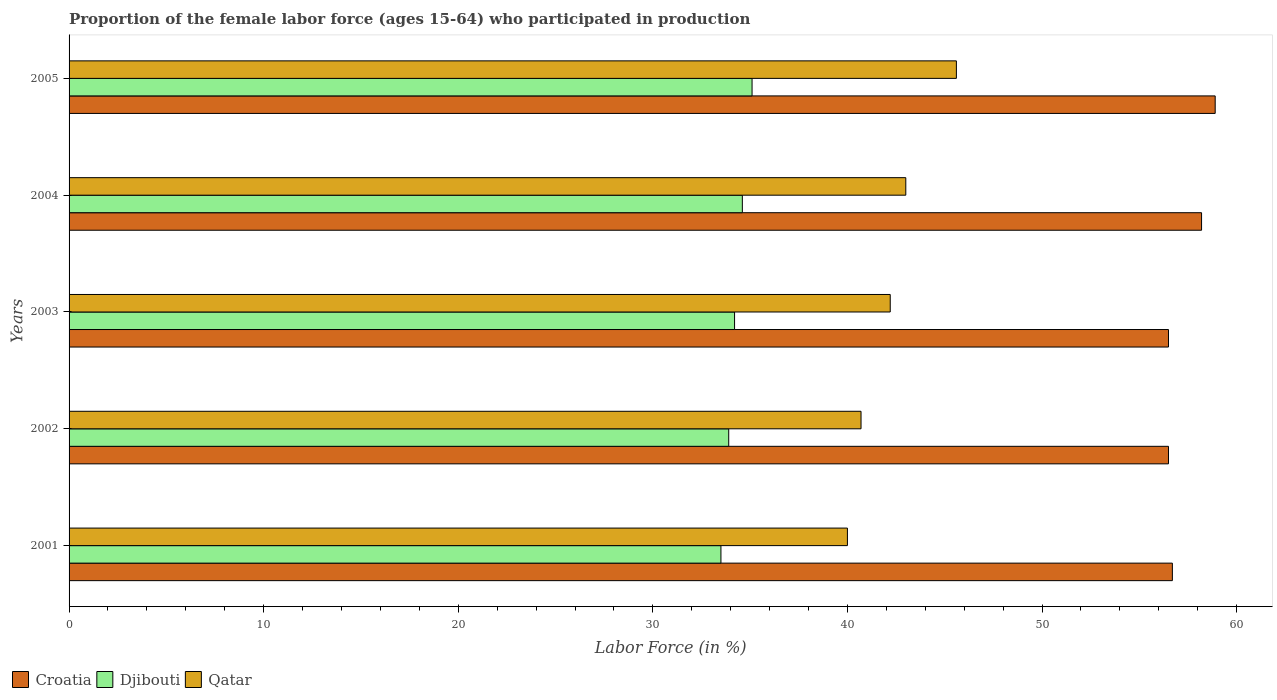How many groups of bars are there?
Offer a very short reply. 5. How many bars are there on the 5th tick from the bottom?
Make the answer very short. 3. What is the proportion of the female labor force who participated in production in Croatia in 2005?
Your answer should be very brief. 58.9. Across all years, what is the maximum proportion of the female labor force who participated in production in Djibouti?
Offer a very short reply. 35.1. Across all years, what is the minimum proportion of the female labor force who participated in production in Qatar?
Give a very brief answer. 40. In which year was the proportion of the female labor force who participated in production in Djibouti minimum?
Provide a short and direct response. 2001. What is the total proportion of the female labor force who participated in production in Djibouti in the graph?
Provide a succinct answer. 171.3. What is the difference between the proportion of the female labor force who participated in production in Qatar in 2002 and that in 2004?
Make the answer very short. -2.3. What is the difference between the proportion of the female labor force who participated in production in Djibouti in 2004 and the proportion of the female labor force who participated in production in Croatia in 2001?
Provide a short and direct response. -22.1. What is the average proportion of the female labor force who participated in production in Qatar per year?
Your response must be concise. 42.3. In the year 2002, what is the difference between the proportion of the female labor force who participated in production in Qatar and proportion of the female labor force who participated in production in Croatia?
Offer a very short reply. -15.8. What is the ratio of the proportion of the female labor force who participated in production in Croatia in 2003 to that in 2004?
Your answer should be compact. 0.97. Is the difference between the proportion of the female labor force who participated in production in Qatar in 2002 and 2005 greater than the difference between the proportion of the female labor force who participated in production in Croatia in 2002 and 2005?
Make the answer very short. No. What is the difference between the highest and the second highest proportion of the female labor force who participated in production in Djibouti?
Offer a terse response. 0.5. What is the difference between the highest and the lowest proportion of the female labor force who participated in production in Djibouti?
Your answer should be compact. 1.6. In how many years, is the proportion of the female labor force who participated in production in Qatar greater than the average proportion of the female labor force who participated in production in Qatar taken over all years?
Make the answer very short. 2. What does the 1st bar from the top in 2003 represents?
Ensure brevity in your answer.  Qatar. What does the 1st bar from the bottom in 2004 represents?
Ensure brevity in your answer.  Croatia. Is it the case that in every year, the sum of the proportion of the female labor force who participated in production in Djibouti and proportion of the female labor force who participated in production in Croatia is greater than the proportion of the female labor force who participated in production in Qatar?
Offer a very short reply. Yes. Are all the bars in the graph horizontal?
Keep it short and to the point. Yes. Does the graph contain grids?
Offer a terse response. No. Where does the legend appear in the graph?
Keep it short and to the point. Bottom left. How many legend labels are there?
Your answer should be very brief. 3. What is the title of the graph?
Ensure brevity in your answer.  Proportion of the female labor force (ages 15-64) who participated in production. Does "Swaziland" appear as one of the legend labels in the graph?
Your answer should be compact. No. What is the Labor Force (in %) in Croatia in 2001?
Offer a terse response. 56.7. What is the Labor Force (in %) in Djibouti in 2001?
Keep it short and to the point. 33.5. What is the Labor Force (in %) in Qatar in 2001?
Your answer should be compact. 40. What is the Labor Force (in %) in Croatia in 2002?
Offer a very short reply. 56.5. What is the Labor Force (in %) in Djibouti in 2002?
Offer a terse response. 33.9. What is the Labor Force (in %) in Qatar in 2002?
Keep it short and to the point. 40.7. What is the Labor Force (in %) of Croatia in 2003?
Your answer should be compact. 56.5. What is the Labor Force (in %) in Djibouti in 2003?
Offer a terse response. 34.2. What is the Labor Force (in %) of Qatar in 2003?
Make the answer very short. 42.2. What is the Labor Force (in %) in Croatia in 2004?
Your response must be concise. 58.2. What is the Labor Force (in %) of Djibouti in 2004?
Keep it short and to the point. 34.6. What is the Labor Force (in %) of Croatia in 2005?
Your response must be concise. 58.9. What is the Labor Force (in %) in Djibouti in 2005?
Your response must be concise. 35.1. What is the Labor Force (in %) of Qatar in 2005?
Give a very brief answer. 45.6. Across all years, what is the maximum Labor Force (in %) of Croatia?
Ensure brevity in your answer.  58.9. Across all years, what is the maximum Labor Force (in %) in Djibouti?
Offer a terse response. 35.1. Across all years, what is the maximum Labor Force (in %) of Qatar?
Your response must be concise. 45.6. Across all years, what is the minimum Labor Force (in %) in Croatia?
Give a very brief answer. 56.5. Across all years, what is the minimum Labor Force (in %) in Djibouti?
Ensure brevity in your answer.  33.5. What is the total Labor Force (in %) of Croatia in the graph?
Provide a succinct answer. 286.8. What is the total Labor Force (in %) in Djibouti in the graph?
Keep it short and to the point. 171.3. What is the total Labor Force (in %) of Qatar in the graph?
Offer a very short reply. 211.5. What is the difference between the Labor Force (in %) in Djibouti in 2001 and that in 2003?
Offer a terse response. -0.7. What is the difference between the Labor Force (in %) in Qatar in 2001 and that in 2003?
Ensure brevity in your answer.  -2.2. What is the difference between the Labor Force (in %) of Croatia in 2001 and that in 2005?
Your answer should be very brief. -2.2. What is the difference between the Labor Force (in %) of Qatar in 2001 and that in 2005?
Your answer should be compact. -5.6. What is the difference between the Labor Force (in %) in Croatia in 2002 and that in 2003?
Your answer should be compact. 0. What is the difference between the Labor Force (in %) of Djibouti in 2002 and that in 2003?
Provide a short and direct response. -0.3. What is the difference between the Labor Force (in %) in Qatar in 2002 and that in 2003?
Give a very brief answer. -1.5. What is the difference between the Labor Force (in %) in Qatar in 2002 and that in 2004?
Provide a succinct answer. -2.3. What is the difference between the Labor Force (in %) in Croatia in 2003 and that in 2005?
Provide a short and direct response. -2.4. What is the difference between the Labor Force (in %) of Qatar in 2003 and that in 2005?
Ensure brevity in your answer.  -3.4. What is the difference between the Labor Force (in %) in Croatia in 2004 and that in 2005?
Offer a terse response. -0.7. What is the difference between the Labor Force (in %) in Croatia in 2001 and the Labor Force (in %) in Djibouti in 2002?
Keep it short and to the point. 22.8. What is the difference between the Labor Force (in %) of Croatia in 2001 and the Labor Force (in %) of Qatar in 2002?
Your answer should be very brief. 16. What is the difference between the Labor Force (in %) in Djibouti in 2001 and the Labor Force (in %) in Qatar in 2002?
Keep it short and to the point. -7.2. What is the difference between the Labor Force (in %) in Djibouti in 2001 and the Labor Force (in %) in Qatar in 2003?
Keep it short and to the point. -8.7. What is the difference between the Labor Force (in %) in Croatia in 2001 and the Labor Force (in %) in Djibouti in 2004?
Provide a short and direct response. 22.1. What is the difference between the Labor Force (in %) of Croatia in 2001 and the Labor Force (in %) of Qatar in 2004?
Ensure brevity in your answer.  13.7. What is the difference between the Labor Force (in %) in Djibouti in 2001 and the Labor Force (in %) in Qatar in 2004?
Your answer should be very brief. -9.5. What is the difference between the Labor Force (in %) in Croatia in 2001 and the Labor Force (in %) in Djibouti in 2005?
Offer a very short reply. 21.6. What is the difference between the Labor Force (in %) in Croatia in 2001 and the Labor Force (in %) in Qatar in 2005?
Ensure brevity in your answer.  11.1. What is the difference between the Labor Force (in %) in Djibouti in 2001 and the Labor Force (in %) in Qatar in 2005?
Your response must be concise. -12.1. What is the difference between the Labor Force (in %) of Croatia in 2002 and the Labor Force (in %) of Djibouti in 2003?
Provide a succinct answer. 22.3. What is the difference between the Labor Force (in %) in Croatia in 2002 and the Labor Force (in %) in Qatar in 2003?
Offer a very short reply. 14.3. What is the difference between the Labor Force (in %) of Croatia in 2002 and the Labor Force (in %) of Djibouti in 2004?
Provide a succinct answer. 21.9. What is the difference between the Labor Force (in %) of Croatia in 2002 and the Labor Force (in %) of Qatar in 2004?
Provide a short and direct response. 13.5. What is the difference between the Labor Force (in %) in Croatia in 2002 and the Labor Force (in %) in Djibouti in 2005?
Provide a short and direct response. 21.4. What is the difference between the Labor Force (in %) of Croatia in 2003 and the Labor Force (in %) of Djibouti in 2004?
Provide a short and direct response. 21.9. What is the difference between the Labor Force (in %) of Croatia in 2003 and the Labor Force (in %) of Qatar in 2004?
Offer a very short reply. 13.5. What is the difference between the Labor Force (in %) of Djibouti in 2003 and the Labor Force (in %) of Qatar in 2004?
Provide a succinct answer. -8.8. What is the difference between the Labor Force (in %) in Croatia in 2003 and the Labor Force (in %) in Djibouti in 2005?
Offer a terse response. 21.4. What is the difference between the Labor Force (in %) in Croatia in 2004 and the Labor Force (in %) in Djibouti in 2005?
Give a very brief answer. 23.1. What is the difference between the Labor Force (in %) in Croatia in 2004 and the Labor Force (in %) in Qatar in 2005?
Give a very brief answer. 12.6. What is the difference between the Labor Force (in %) in Djibouti in 2004 and the Labor Force (in %) in Qatar in 2005?
Your response must be concise. -11. What is the average Labor Force (in %) of Croatia per year?
Offer a very short reply. 57.36. What is the average Labor Force (in %) of Djibouti per year?
Your answer should be very brief. 34.26. What is the average Labor Force (in %) of Qatar per year?
Ensure brevity in your answer.  42.3. In the year 2001, what is the difference between the Labor Force (in %) of Croatia and Labor Force (in %) of Djibouti?
Offer a very short reply. 23.2. In the year 2002, what is the difference between the Labor Force (in %) of Croatia and Labor Force (in %) of Djibouti?
Offer a terse response. 22.6. In the year 2003, what is the difference between the Labor Force (in %) in Croatia and Labor Force (in %) in Djibouti?
Offer a terse response. 22.3. In the year 2003, what is the difference between the Labor Force (in %) of Croatia and Labor Force (in %) of Qatar?
Your response must be concise. 14.3. In the year 2004, what is the difference between the Labor Force (in %) in Croatia and Labor Force (in %) in Djibouti?
Your answer should be very brief. 23.6. In the year 2005, what is the difference between the Labor Force (in %) of Croatia and Labor Force (in %) of Djibouti?
Provide a succinct answer. 23.8. What is the ratio of the Labor Force (in %) in Croatia in 2001 to that in 2002?
Give a very brief answer. 1. What is the ratio of the Labor Force (in %) of Qatar in 2001 to that in 2002?
Ensure brevity in your answer.  0.98. What is the ratio of the Labor Force (in %) in Djibouti in 2001 to that in 2003?
Give a very brief answer. 0.98. What is the ratio of the Labor Force (in %) of Qatar in 2001 to that in 2003?
Your answer should be very brief. 0.95. What is the ratio of the Labor Force (in %) in Croatia in 2001 to that in 2004?
Keep it short and to the point. 0.97. What is the ratio of the Labor Force (in %) of Djibouti in 2001 to that in 2004?
Your response must be concise. 0.97. What is the ratio of the Labor Force (in %) of Qatar in 2001 to that in 2004?
Your response must be concise. 0.93. What is the ratio of the Labor Force (in %) of Croatia in 2001 to that in 2005?
Provide a short and direct response. 0.96. What is the ratio of the Labor Force (in %) in Djibouti in 2001 to that in 2005?
Make the answer very short. 0.95. What is the ratio of the Labor Force (in %) in Qatar in 2001 to that in 2005?
Offer a very short reply. 0.88. What is the ratio of the Labor Force (in %) of Qatar in 2002 to that in 2003?
Your answer should be compact. 0.96. What is the ratio of the Labor Force (in %) of Croatia in 2002 to that in 2004?
Provide a short and direct response. 0.97. What is the ratio of the Labor Force (in %) in Djibouti in 2002 to that in 2004?
Your answer should be very brief. 0.98. What is the ratio of the Labor Force (in %) of Qatar in 2002 to that in 2004?
Provide a short and direct response. 0.95. What is the ratio of the Labor Force (in %) in Croatia in 2002 to that in 2005?
Give a very brief answer. 0.96. What is the ratio of the Labor Force (in %) in Djibouti in 2002 to that in 2005?
Ensure brevity in your answer.  0.97. What is the ratio of the Labor Force (in %) of Qatar in 2002 to that in 2005?
Offer a terse response. 0.89. What is the ratio of the Labor Force (in %) in Croatia in 2003 to that in 2004?
Make the answer very short. 0.97. What is the ratio of the Labor Force (in %) in Djibouti in 2003 to that in 2004?
Keep it short and to the point. 0.99. What is the ratio of the Labor Force (in %) of Qatar in 2003 to that in 2004?
Give a very brief answer. 0.98. What is the ratio of the Labor Force (in %) in Croatia in 2003 to that in 2005?
Make the answer very short. 0.96. What is the ratio of the Labor Force (in %) in Djibouti in 2003 to that in 2005?
Make the answer very short. 0.97. What is the ratio of the Labor Force (in %) of Qatar in 2003 to that in 2005?
Ensure brevity in your answer.  0.93. What is the ratio of the Labor Force (in %) of Croatia in 2004 to that in 2005?
Your response must be concise. 0.99. What is the ratio of the Labor Force (in %) in Djibouti in 2004 to that in 2005?
Offer a terse response. 0.99. What is the ratio of the Labor Force (in %) in Qatar in 2004 to that in 2005?
Provide a succinct answer. 0.94. What is the difference between the highest and the second highest Labor Force (in %) of Croatia?
Provide a succinct answer. 0.7. What is the difference between the highest and the second highest Labor Force (in %) in Djibouti?
Keep it short and to the point. 0.5. What is the difference between the highest and the second highest Labor Force (in %) in Qatar?
Your response must be concise. 2.6. What is the difference between the highest and the lowest Labor Force (in %) in Djibouti?
Your answer should be compact. 1.6. 